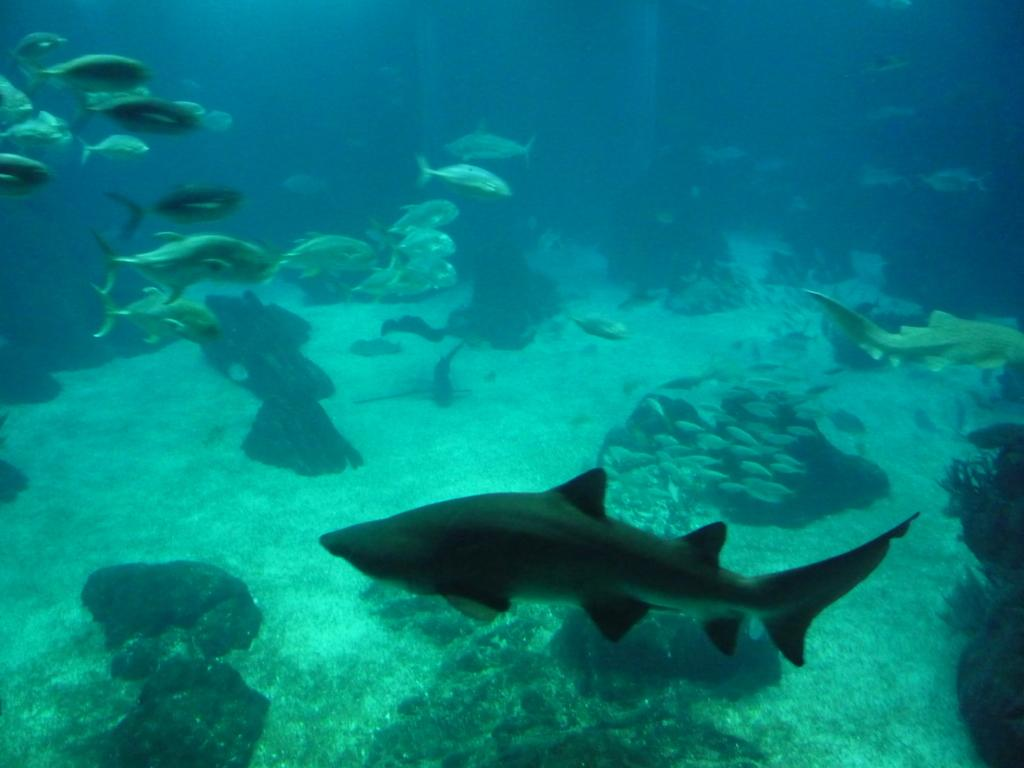What type of animals can be seen in the image? There is a group of fishes in the image. What are the fishes and other marine creatures doing in the image? They are swimming in the water. What type of natural formations can be seen in the image? There are rocks visible in the image. What else can be seen in the image besides the fishes and rocks? There are other objects present in the image. How does the turkey feel about the attention it is receiving in the image? There is no turkey present in the image; it features a group of fishes and other marine creatures swimming in the water. 